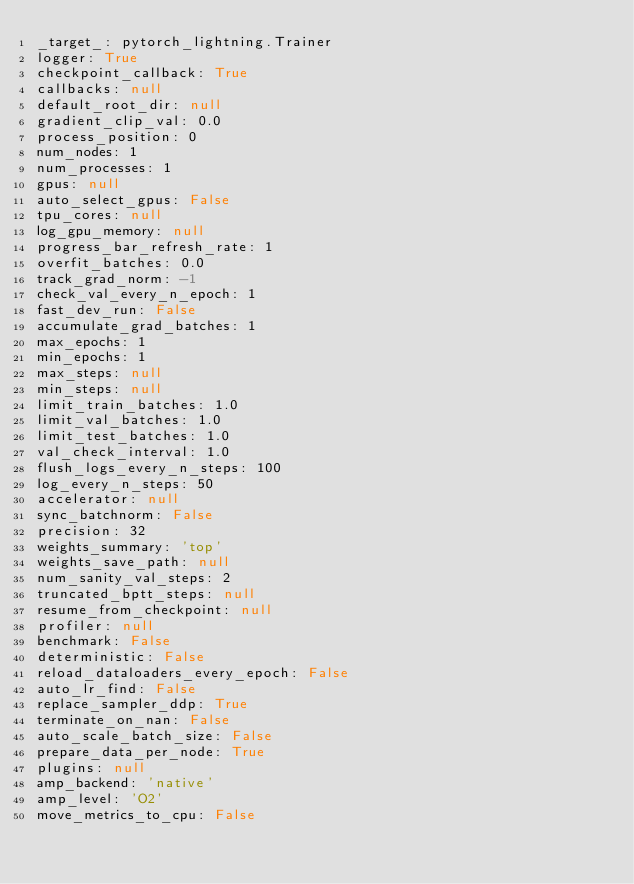Convert code to text. <code><loc_0><loc_0><loc_500><loc_500><_YAML_>_target_: pytorch_lightning.Trainer
logger: True
checkpoint_callback: True
callbacks: null
default_root_dir: null
gradient_clip_val: 0.0
process_position: 0
num_nodes: 1
num_processes: 1
gpus: null
auto_select_gpus: False
tpu_cores: null
log_gpu_memory: null
progress_bar_refresh_rate: 1
overfit_batches: 0.0
track_grad_norm: -1
check_val_every_n_epoch: 1
fast_dev_run: False
accumulate_grad_batches: 1
max_epochs: 1
min_epochs: 1
max_steps: null
min_steps: null
limit_train_batches: 1.0
limit_val_batches: 1.0
limit_test_batches: 1.0
val_check_interval: 1.0
flush_logs_every_n_steps: 100
log_every_n_steps: 50
accelerator: null
sync_batchnorm: False
precision: 32
weights_summary: 'top'
weights_save_path: null
num_sanity_val_steps: 2
truncated_bptt_steps: null
resume_from_checkpoint: null
profiler: null
benchmark: False
deterministic: False
reload_dataloaders_every_epoch: False
auto_lr_find: False
replace_sampler_ddp: True
terminate_on_nan: False
auto_scale_batch_size: False
prepare_data_per_node: True
plugins: null
amp_backend: 'native'
amp_level: 'O2'
move_metrics_to_cpu: False
</code> 